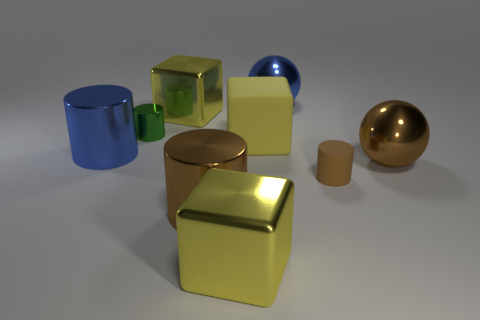Add 1 tiny brown matte objects. How many objects exist? 10 Subtract all cubes. How many objects are left? 6 Add 3 brown cylinders. How many brown cylinders exist? 5 Subtract 1 brown cylinders. How many objects are left? 8 Subtract all spheres. Subtract all yellow matte objects. How many objects are left? 6 Add 8 large yellow metallic objects. How many large yellow metallic objects are left? 10 